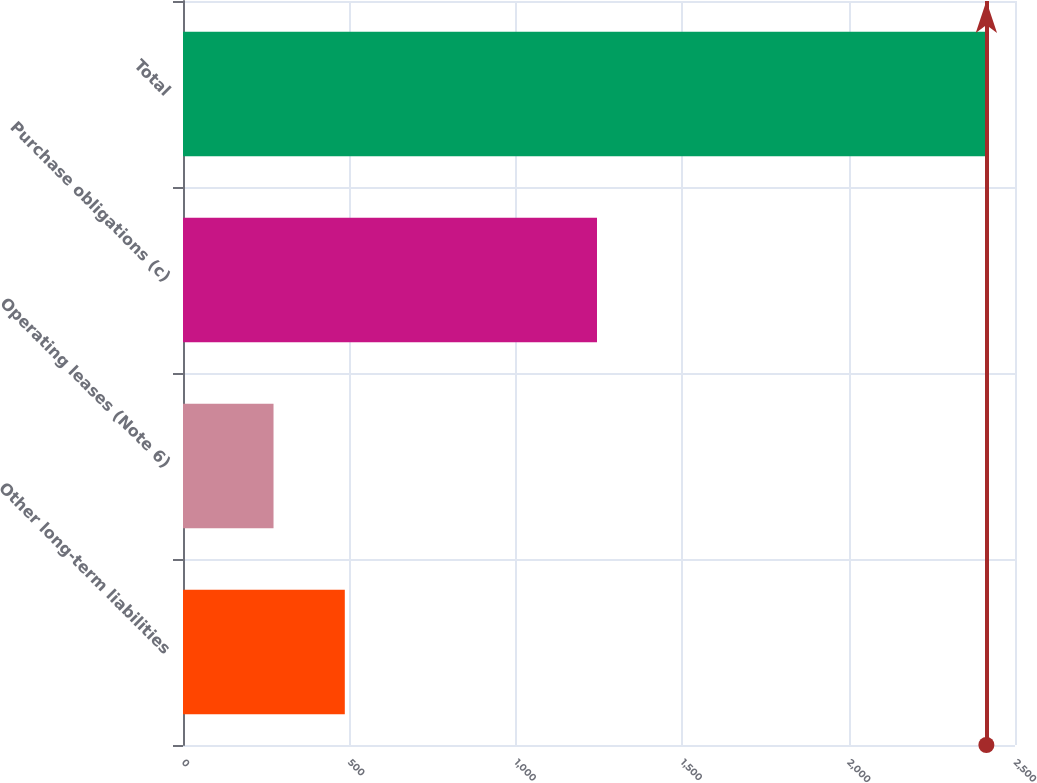Convert chart to OTSL. <chart><loc_0><loc_0><loc_500><loc_500><bar_chart><fcel>Other long-term liabilities<fcel>Operating leases (Note 6)<fcel>Purchase obligations (c)<fcel>Total<nl><fcel>486.2<fcel>272<fcel>1244<fcel>2414<nl></chart> 